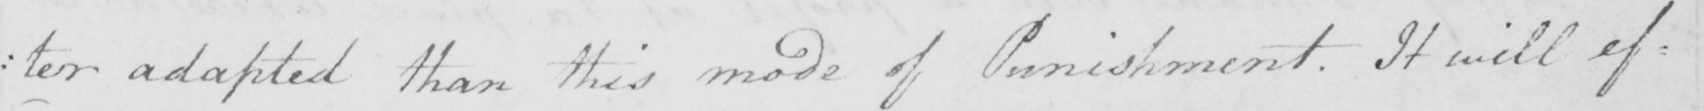Transcribe the text shown in this historical manuscript line. : ter adapted than this mode of Punishment . It will ef= 